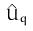<formula> <loc_0><loc_0><loc_500><loc_500>\hat { U } _ { q }</formula> 